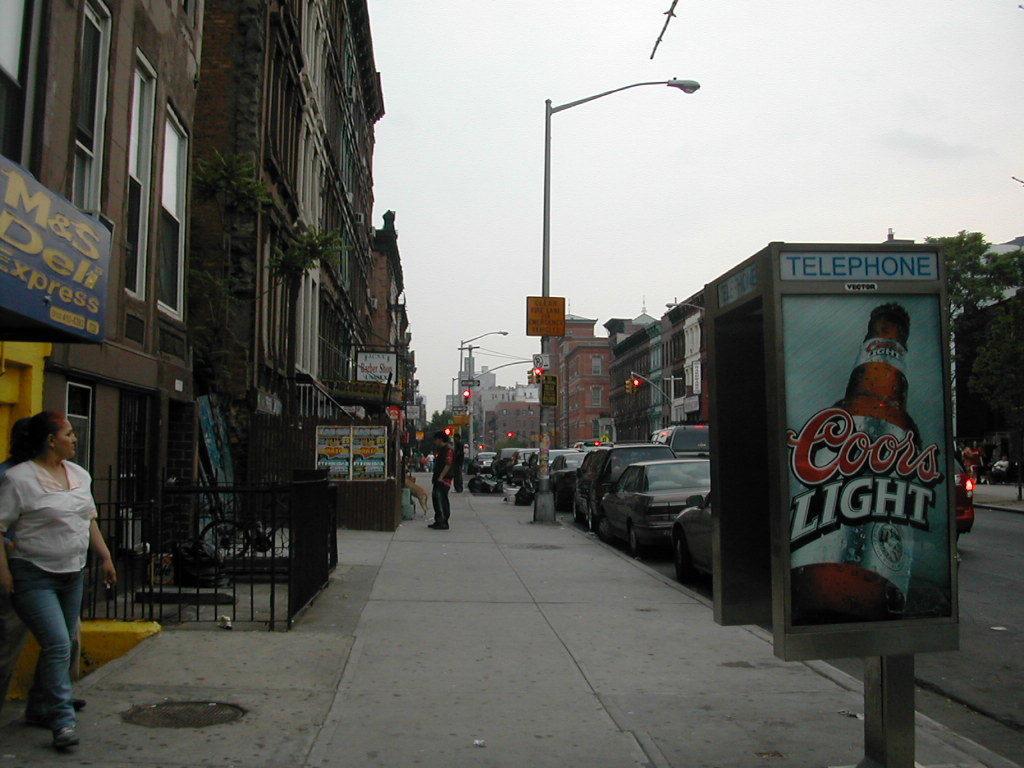Could you give a brief overview of what you see in this image? In this picture we can see some standing and a woman is walking on the path and on the path there is a dog. On the left side of the people there is an iron grills, name board and buildings. On the right side of the people there are poles with lights and a telephone to the pole and some vehicles parked on the road. On the right side of the vehicles there are trees and behind the buildings there is the sky. 